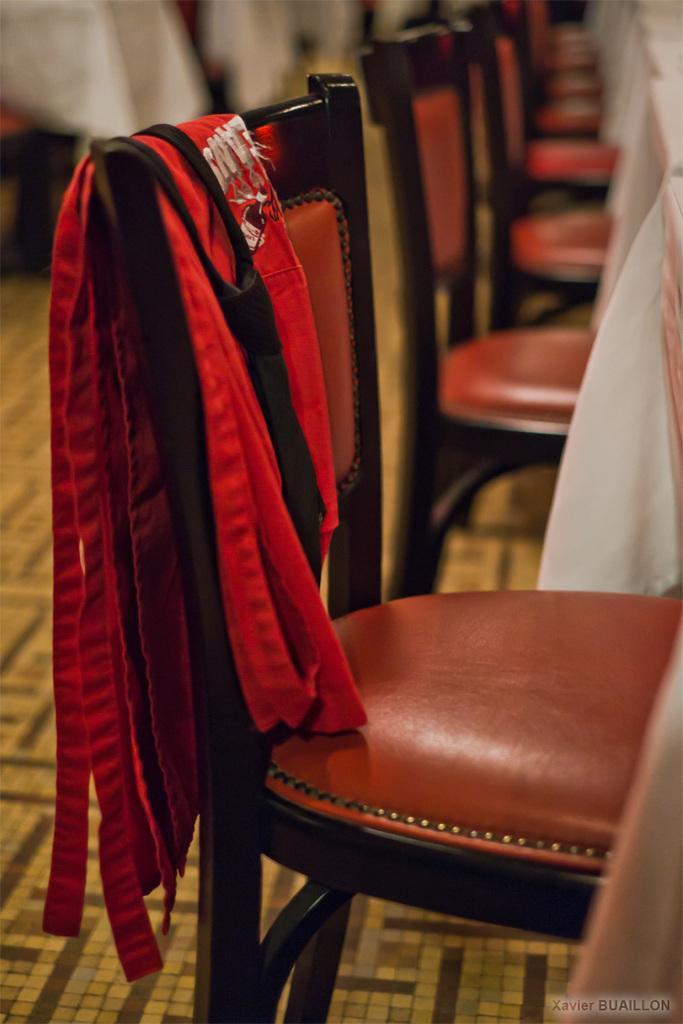Please provide a concise description of this image. In the image we can see there are many chairs and on the chair there is a cloth. Here we can see the floor and the background is blurred. On the bottom right we can see the watermark.  